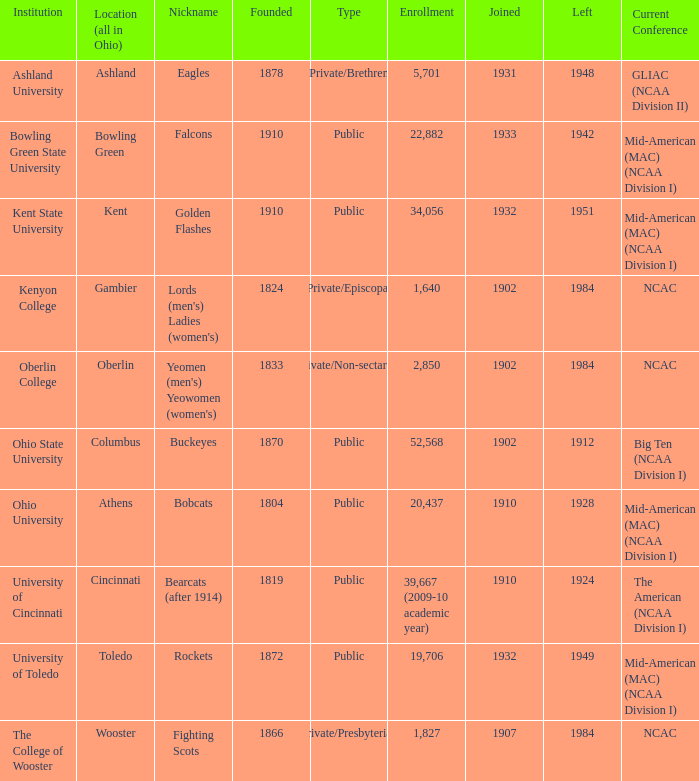For which year of foundation is the maximum enrollment associated? 1910.0. 